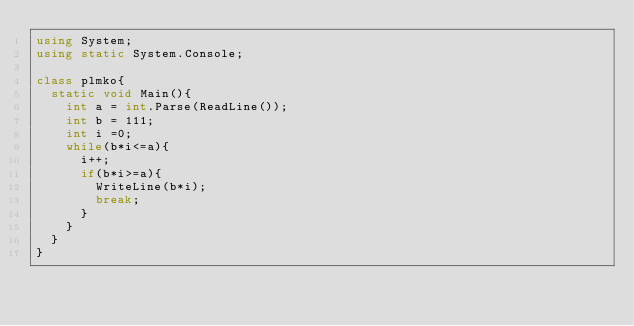<code> <loc_0><loc_0><loc_500><loc_500><_C#_>using System;
using static System.Console;

class plmko{
  static void Main(){
    int a = int.Parse(ReadLine());
    int b = 111;
    int i =0;
    while(b*i<=a){
      i++;
      if(b*i>=a){
        WriteLine(b*i);
        break;
      }
    }
  }
}</code> 